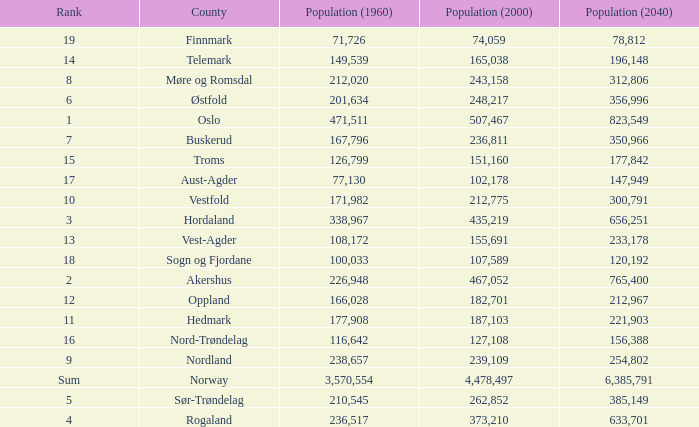What was the population of a county in 2040 that had a population less than 108,172 in 2000 and less than 107,589 in 1960? 2.0. 